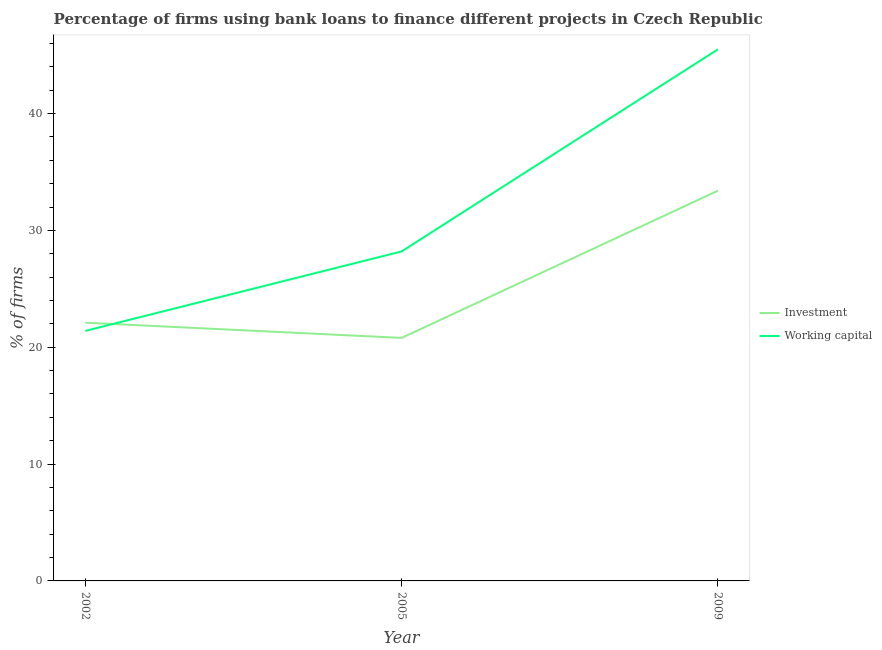How many different coloured lines are there?
Make the answer very short. 2. Does the line corresponding to percentage of firms using banks to finance working capital intersect with the line corresponding to percentage of firms using banks to finance investment?
Your response must be concise. Yes. Is the number of lines equal to the number of legend labels?
Provide a succinct answer. Yes. What is the percentage of firms using banks to finance working capital in 2009?
Keep it short and to the point. 45.5. Across all years, what is the maximum percentage of firms using banks to finance working capital?
Offer a terse response. 45.5. Across all years, what is the minimum percentage of firms using banks to finance working capital?
Your response must be concise. 21.4. In which year was the percentage of firms using banks to finance working capital maximum?
Offer a terse response. 2009. In which year was the percentage of firms using banks to finance investment minimum?
Provide a short and direct response. 2005. What is the total percentage of firms using banks to finance working capital in the graph?
Your answer should be very brief. 95.1. What is the difference between the percentage of firms using banks to finance investment in 2002 and that in 2009?
Keep it short and to the point. -11.3. What is the difference between the percentage of firms using banks to finance working capital in 2009 and the percentage of firms using banks to finance investment in 2005?
Give a very brief answer. 24.7. What is the average percentage of firms using banks to finance investment per year?
Your answer should be compact. 25.43. In the year 2005, what is the difference between the percentage of firms using banks to finance investment and percentage of firms using banks to finance working capital?
Your response must be concise. -7.4. What is the ratio of the percentage of firms using banks to finance working capital in 2002 to that in 2005?
Offer a very short reply. 0.76. Is the difference between the percentage of firms using banks to finance working capital in 2002 and 2009 greater than the difference between the percentage of firms using banks to finance investment in 2002 and 2009?
Your answer should be compact. No. What is the difference between the highest and the second highest percentage of firms using banks to finance working capital?
Your answer should be compact. 17.3. What is the difference between the highest and the lowest percentage of firms using banks to finance investment?
Make the answer very short. 12.6. Is the sum of the percentage of firms using banks to finance investment in 2005 and 2009 greater than the maximum percentage of firms using banks to finance working capital across all years?
Offer a very short reply. Yes. Is the percentage of firms using banks to finance working capital strictly less than the percentage of firms using banks to finance investment over the years?
Ensure brevity in your answer.  No. Does the graph contain any zero values?
Give a very brief answer. No. Does the graph contain grids?
Provide a short and direct response. No. Where does the legend appear in the graph?
Your answer should be compact. Center right. How are the legend labels stacked?
Your answer should be very brief. Vertical. What is the title of the graph?
Your answer should be compact. Percentage of firms using bank loans to finance different projects in Czech Republic. What is the label or title of the X-axis?
Your answer should be very brief. Year. What is the label or title of the Y-axis?
Keep it short and to the point. % of firms. What is the % of firms in Investment in 2002?
Offer a very short reply. 22.1. What is the % of firms of Working capital in 2002?
Your answer should be compact. 21.4. What is the % of firms in Investment in 2005?
Your answer should be very brief. 20.8. What is the % of firms in Working capital in 2005?
Your answer should be compact. 28.2. What is the % of firms in Investment in 2009?
Your response must be concise. 33.4. What is the % of firms in Working capital in 2009?
Your response must be concise. 45.5. Across all years, what is the maximum % of firms in Investment?
Offer a very short reply. 33.4. Across all years, what is the maximum % of firms in Working capital?
Provide a succinct answer. 45.5. Across all years, what is the minimum % of firms in Investment?
Make the answer very short. 20.8. Across all years, what is the minimum % of firms of Working capital?
Make the answer very short. 21.4. What is the total % of firms of Investment in the graph?
Offer a very short reply. 76.3. What is the total % of firms of Working capital in the graph?
Give a very brief answer. 95.1. What is the difference between the % of firms of Investment in 2002 and that in 2005?
Provide a succinct answer. 1.3. What is the difference between the % of firms in Working capital in 2002 and that in 2005?
Your answer should be compact. -6.8. What is the difference between the % of firms in Investment in 2002 and that in 2009?
Your answer should be very brief. -11.3. What is the difference between the % of firms in Working capital in 2002 and that in 2009?
Give a very brief answer. -24.1. What is the difference between the % of firms in Working capital in 2005 and that in 2009?
Keep it short and to the point. -17.3. What is the difference between the % of firms of Investment in 2002 and the % of firms of Working capital in 2009?
Ensure brevity in your answer.  -23.4. What is the difference between the % of firms in Investment in 2005 and the % of firms in Working capital in 2009?
Ensure brevity in your answer.  -24.7. What is the average % of firms of Investment per year?
Offer a terse response. 25.43. What is the average % of firms of Working capital per year?
Offer a terse response. 31.7. In the year 2002, what is the difference between the % of firms of Investment and % of firms of Working capital?
Provide a succinct answer. 0.7. In the year 2009, what is the difference between the % of firms in Investment and % of firms in Working capital?
Provide a succinct answer. -12.1. What is the ratio of the % of firms in Working capital in 2002 to that in 2005?
Ensure brevity in your answer.  0.76. What is the ratio of the % of firms of Investment in 2002 to that in 2009?
Your answer should be very brief. 0.66. What is the ratio of the % of firms of Working capital in 2002 to that in 2009?
Your answer should be compact. 0.47. What is the ratio of the % of firms of Investment in 2005 to that in 2009?
Provide a short and direct response. 0.62. What is the ratio of the % of firms in Working capital in 2005 to that in 2009?
Provide a succinct answer. 0.62. What is the difference between the highest and the lowest % of firms in Investment?
Provide a succinct answer. 12.6. What is the difference between the highest and the lowest % of firms of Working capital?
Offer a very short reply. 24.1. 